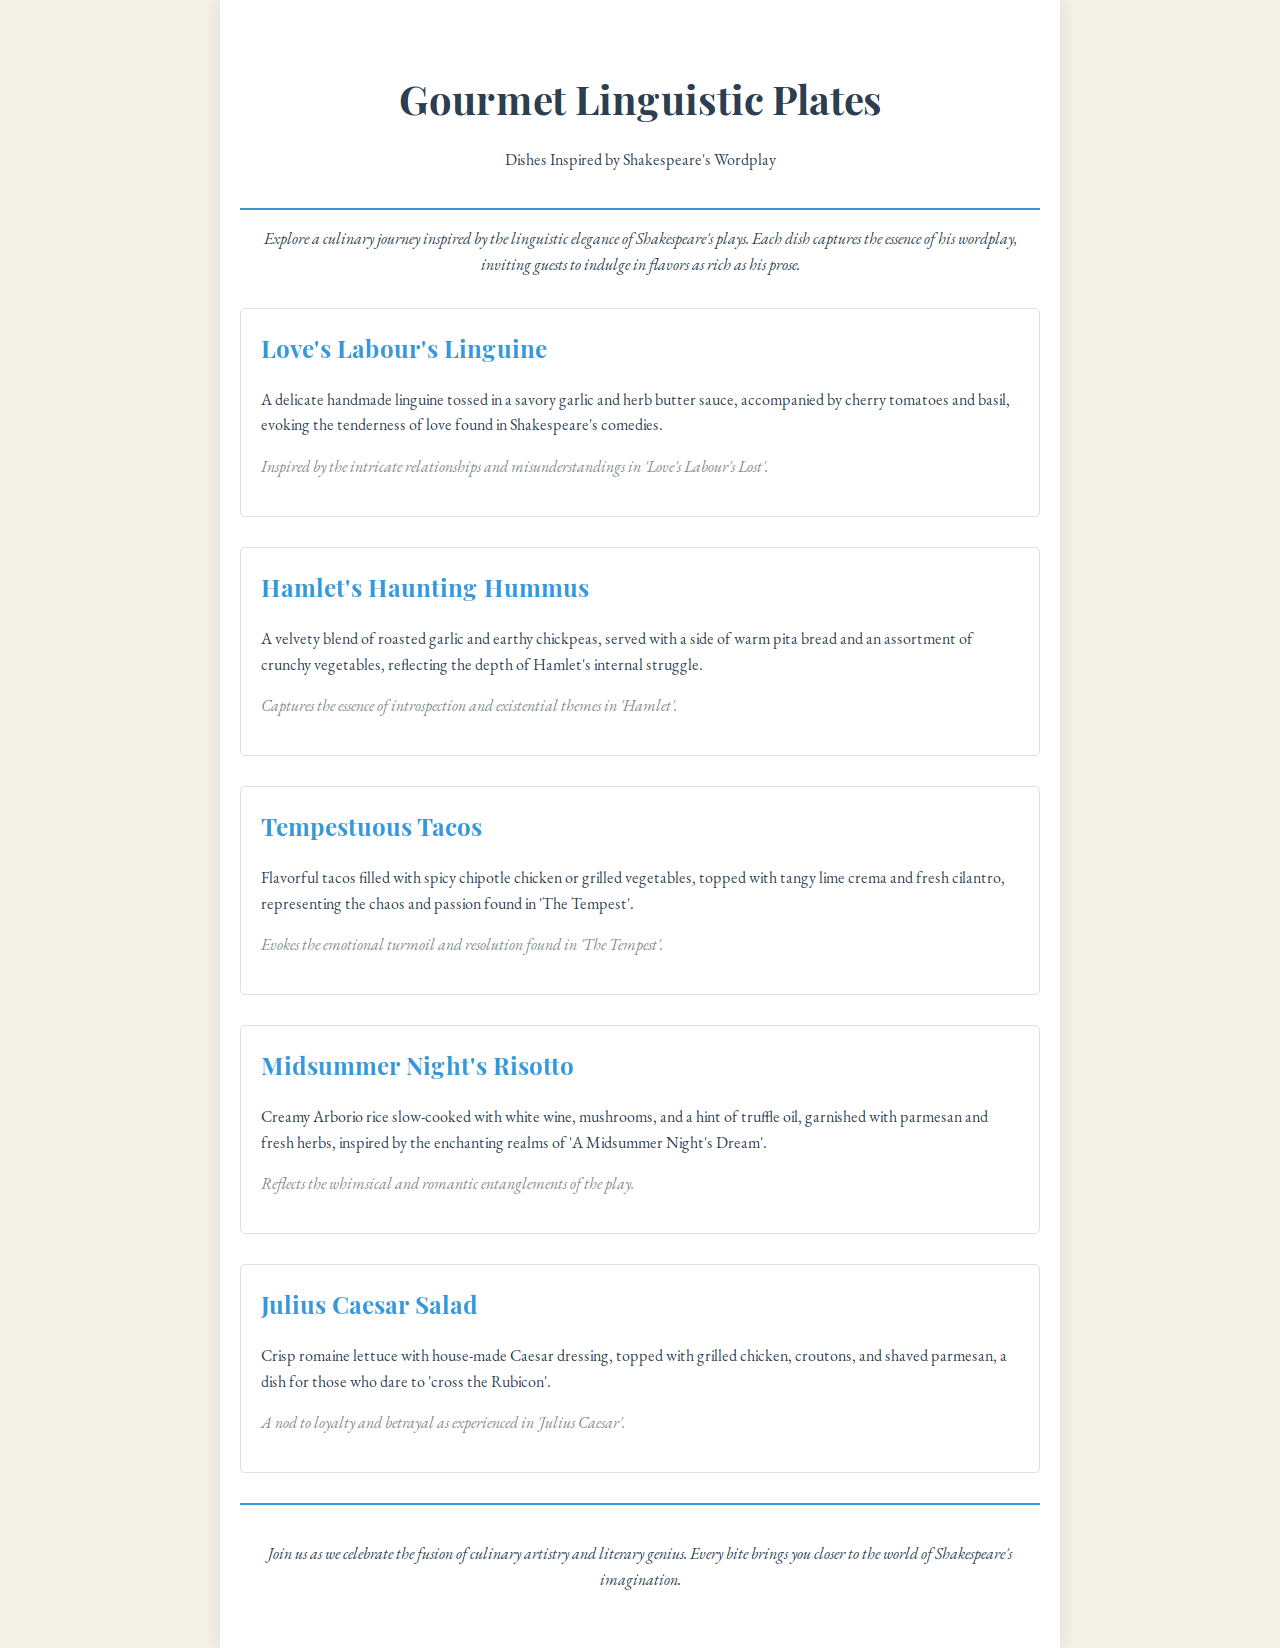What is the title of the menu? The title of the menu is prominently displayed at the top, introducing the theme of the dishes.
Answer: Gourmet Linguistic Plates How many menu items are listed? The document includes five distinct menu items, each with a description and inspiration.
Answer: 5 What type of pasta is used in Love's Labour's Linguine? The description specifies the type of pasta featured in this dish, highlighting its handmade nature.
Answer: linguine What dish is inspired by Hamlet? The menu lists a specific dish that captures themes related to Hamlet's character and story.
Answer: Hamlet's Haunting Hummus Which dish reflects the whimsical entanglements of A Midsummer Night's Dream? The inspiration for the dish relates directly to the play, reflecting its unique qualities.
Answer: Midsummer Night's Risotto What ingredient tops the Julius Caesar Salad? The description mentions a specific topping that completes the salad.
Answer: shaved parmesan Which flavor profiles are represented in Tempestuous Tacos? The description identifies key flavors that define this particular dish, relating to its inspiration.
Answer: spicy chipotle chicken or grilled vegetables What does the introduction invite guests to do? The introduction sets the tone for the dining experience by emphasizing the interplay of culinary and literary themes.
Answer: explore a culinary journey 